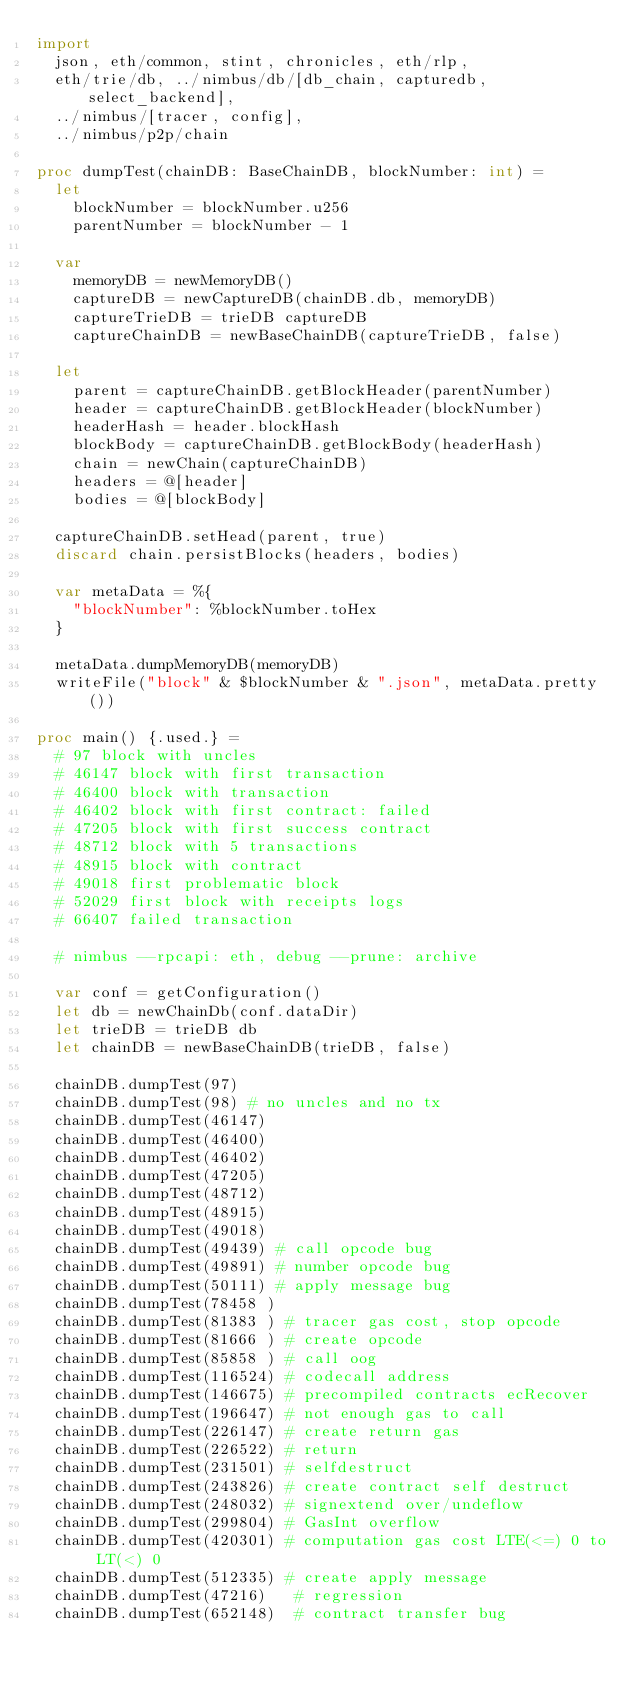<code> <loc_0><loc_0><loc_500><loc_500><_Nim_>import
  json, eth/common, stint, chronicles, eth/rlp,
  eth/trie/db, ../nimbus/db/[db_chain, capturedb, select_backend],
  ../nimbus/[tracer, config],
  ../nimbus/p2p/chain

proc dumpTest(chainDB: BaseChainDB, blockNumber: int) =
  let
    blockNumber = blockNumber.u256
    parentNumber = blockNumber - 1

  var
    memoryDB = newMemoryDB()
    captureDB = newCaptureDB(chainDB.db, memoryDB)
    captureTrieDB = trieDB captureDB
    captureChainDB = newBaseChainDB(captureTrieDB, false)

  let
    parent = captureChainDB.getBlockHeader(parentNumber)
    header = captureChainDB.getBlockHeader(blockNumber)
    headerHash = header.blockHash
    blockBody = captureChainDB.getBlockBody(headerHash)
    chain = newChain(captureChainDB)
    headers = @[header]
    bodies = @[blockBody]

  captureChainDB.setHead(parent, true)
  discard chain.persistBlocks(headers, bodies)

  var metaData = %{
    "blockNumber": %blockNumber.toHex
  }

  metaData.dumpMemoryDB(memoryDB)
  writeFile("block" & $blockNumber & ".json", metaData.pretty())

proc main() {.used.} =
  # 97 block with uncles
  # 46147 block with first transaction
  # 46400 block with transaction
  # 46402 block with first contract: failed
  # 47205 block with first success contract
  # 48712 block with 5 transactions
  # 48915 block with contract
  # 49018 first problematic block
  # 52029 first block with receipts logs
  # 66407 failed transaction

  # nimbus --rpcapi: eth, debug --prune: archive

  var conf = getConfiguration()
  let db = newChainDb(conf.dataDir)
  let trieDB = trieDB db
  let chainDB = newBaseChainDB(trieDB, false)

  chainDB.dumpTest(97)
  chainDB.dumpTest(98) # no uncles and no tx
  chainDB.dumpTest(46147)
  chainDB.dumpTest(46400)
  chainDB.dumpTest(46402)
  chainDB.dumpTest(47205)
  chainDB.dumpTest(48712)
  chainDB.dumpTest(48915)
  chainDB.dumpTest(49018)
  chainDB.dumpTest(49439) # call opcode bug
  chainDB.dumpTest(49891) # number opcode bug
  chainDB.dumpTest(50111) # apply message bug
  chainDB.dumpTest(78458 )
  chainDB.dumpTest(81383 ) # tracer gas cost, stop opcode
  chainDB.dumpTest(81666 ) # create opcode
  chainDB.dumpTest(85858 ) # call oog
  chainDB.dumpTest(116524) # codecall address
  chainDB.dumpTest(146675) # precompiled contracts ecRecover
  chainDB.dumpTest(196647) # not enough gas to call
  chainDB.dumpTest(226147) # create return gas
  chainDB.dumpTest(226522) # return
  chainDB.dumpTest(231501) # selfdestruct
  chainDB.dumpTest(243826) # create contract self destruct
  chainDB.dumpTest(248032) # signextend over/undeflow
  chainDB.dumpTest(299804) # GasInt overflow
  chainDB.dumpTest(420301) # computation gas cost LTE(<=) 0 to LT(<) 0
  chainDB.dumpTest(512335) # create apply message
  chainDB.dumpTest(47216)   # regression
  chainDB.dumpTest(652148)  # contract transfer bug</code> 